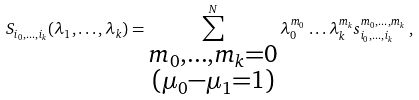<formula> <loc_0><loc_0><loc_500><loc_500>S _ { i _ { 0 } , \dots , i _ { k } } ( \lambda _ { 1 } , \dots , \lambda _ { k } ) = \sum _ { \substack { m _ { 0 } , \dots , m _ { k } = 0 \\ ( \mu _ { 0 } - \mu _ { 1 } = 1 ) } } ^ { N } \lambda _ { 0 } ^ { m _ { 0 } } \dots \lambda _ { k } ^ { m _ { k } } s ^ { m _ { 0 } , \dots , m _ { k } } _ { i _ { 0 } , \dots , i _ { k } } \, ,</formula> 